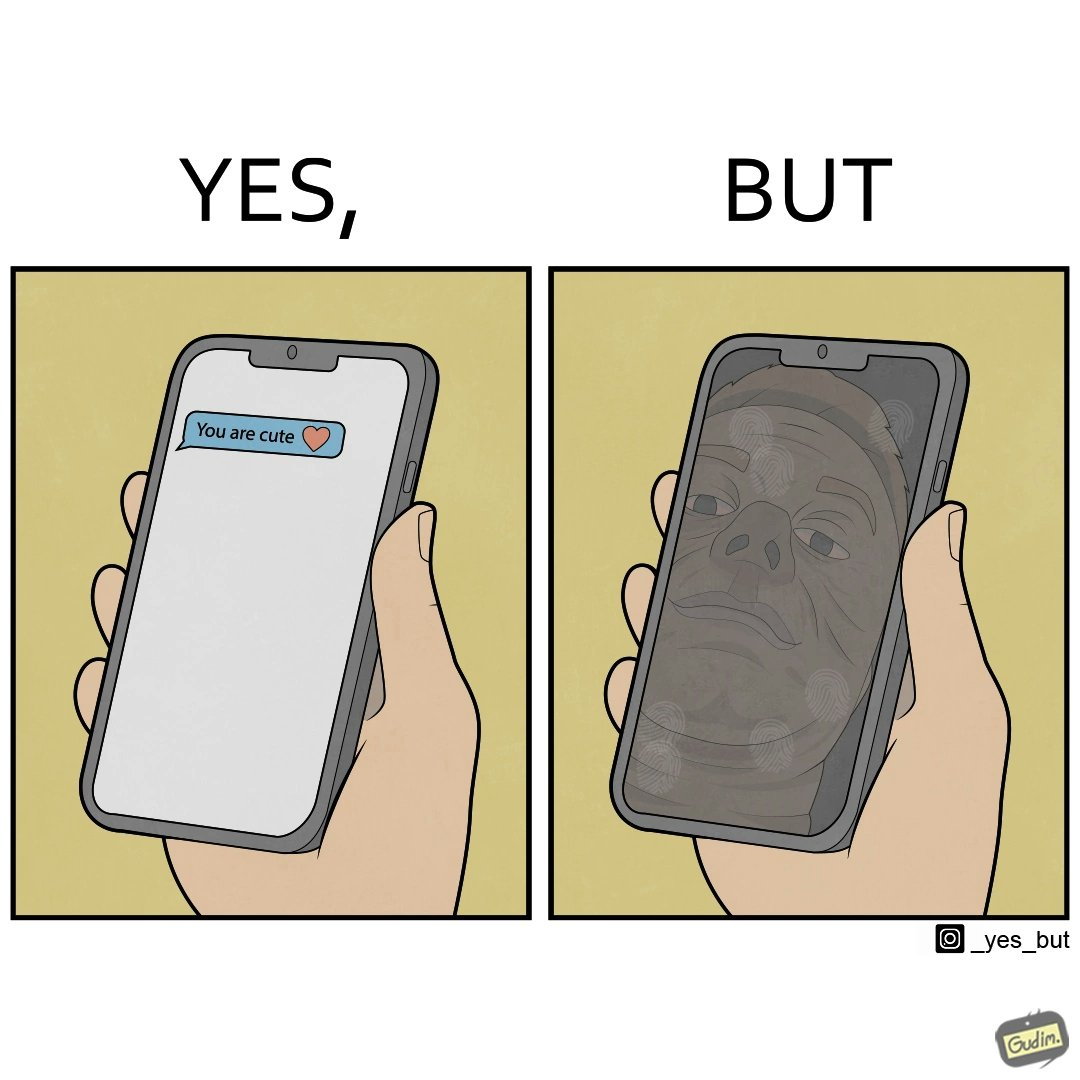Is this a satirical image? Yes, this image is satirical. 